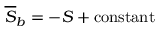<formula> <loc_0><loc_0><loc_500><loc_500>\overline { S } _ { b } = - S + c o n s t a n t</formula> 